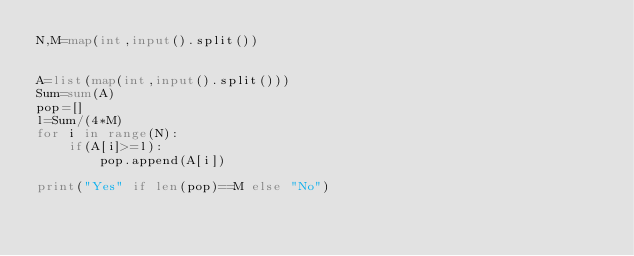<code> <loc_0><loc_0><loc_500><loc_500><_Python_>N,M=map(int,input().split())


A=list(map(int,input().split()))
Sum=sum(A)
pop=[]
l=Sum/(4*M)
for i in range(N):
    if(A[i]>=l):
        pop.append(A[i])
        
print("Yes" if len(pop)==M else "No")</code> 